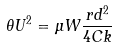Convert formula to latex. <formula><loc_0><loc_0><loc_500><loc_500>\theta U ^ { 2 } = \mu W \frac { r d ^ { 2 } } { 4 C k }</formula> 